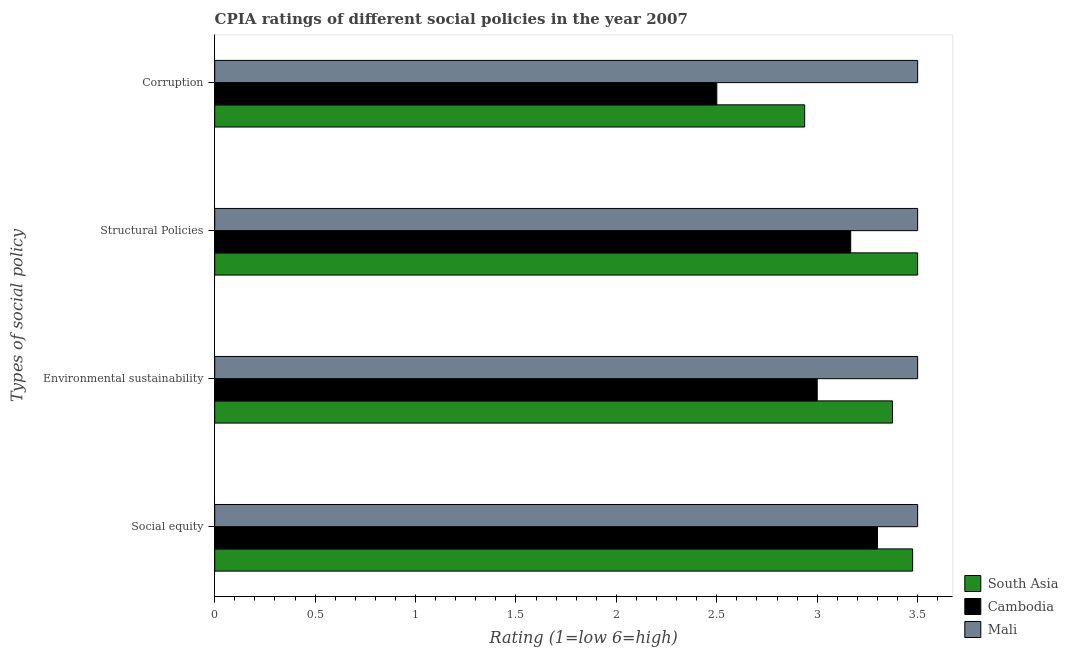How many groups of bars are there?
Provide a succinct answer. 4. Are the number of bars per tick equal to the number of legend labels?
Your response must be concise. Yes. Are the number of bars on each tick of the Y-axis equal?
Provide a succinct answer. Yes. How many bars are there on the 1st tick from the top?
Ensure brevity in your answer.  3. What is the label of the 4th group of bars from the top?
Ensure brevity in your answer.  Social equity. Across all countries, what is the maximum cpia rating of environmental sustainability?
Your response must be concise. 3.5. Across all countries, what is the minimum cpia rating of structural policies?
Ensure brevity in your answer.  3.17. In which country was the cpia rating of structural policies maximum?
Your answer should be very brief. South Asia. In which country was the cpia rating of corruption minimum?
Offer a terse response. Cambodia. What is the total cpia rating of environmental sustainability in the graph?
Offer a terse response. 9.88. What is the difference between the cpia rating of structural policies in South Asia and that in Cambodia?
Your response must be concise. 0.33. What is the difference between the cpia rating of corruption in South Asia and the cpia rating of structural policies in Cambodia?
Make the answer very short. -0.23. What is the average cpia rating of structural policies per country?
Make the answer very short. 3.39. What is the difference between the cpia rating of corruption and cpia rating of structural policies in Cambodia?
Offer a very short reply. -0.67. What is the ratio of the cpia rating of corruption in South Asia to that in Cambodia?
Give a very brief answer. 1.18. Is the difference between the cpia rating of social equity in Cambodia and Mali greater than the difference between the cpia rating of corruption in Cambodia and Mali?
Make the answer very short. Yes. What is the difference between the highest and the second highest cpia rating of corruption?
Offer a terse response. 0.56. What is the difference between the highest and the lowest cpia rating of environmental sustainability?
Your answer should be very brief. 0.5. In how many countries, is the cpia rating of corruption greater than the average cpia rating of corruption taken over all countries?
Keep it short and to the point. 1. Is the sum of the cpia rating of structural policies in Mali and Cambodia greater than the maximum cpia rating of corruption across all countries?
Ensure brevity in your answer.  Yes. Is it the case that in every country, the sum of the cpia rating of structural policies and cpia rating of corruption is greater than the sum of cpia rating of social equity and cpia rating of environmental sustainability?
Your answer should be very brief. No. What does the 3rd bar from the top in Structural Policies represents?
Give a very brief answer. South Asia. What does the 2nd bar from the bottom in Structural Policies represents?
Provide a succinct answer. Cambodia. What is the difference between two consecutive major ticks on the X-axis?
Your response must be concise. 0.5. Are the values on the major ticks of X-axis written in scientific E-notation?
Your answer should be compact. No. Does the graph contain any zero values?
Make the answer very short. No. Does the graph contain grids?
Provide a succinct answer. No. How many legend labels are there?
Keep it short and to the point. 3. How are the legend labels stacked?
Keep it short and to the point. Vertical. What is the title of the graph?
Give a very brief answer. CPIA ratings of different social policies in the year 2007. Does "High income: nonOECD" appear as one of the legend labels in the graph?
Your answer should be compact. No. What is the label or title of the Y-axis?
Your response must be concise. Types of social policy. What is the Rating (1=low 6=high) of South Asia in Social equity?
Your answer should be compact. 3.48. What is the Rating (1=low 6=high) in Mali in Social equity?
Offer a very short reply. 3.5. What is the Rating (1=low 6=high) of South Asia in Environmental sustainability?
Give a very brief answer. 3.38. What is the Rating (1=low 6=high) in Cambodia in Environmental sustainability?
Your response must be concise. 3. What is the Rating (1=low 6=high) in Mali in Environmental sustainability?
Provide a short and direct response. 3.5. What is the Rating (1=low 6=high) in South Asia in Structural Policies?
Provide a succinct answer. 3.5. What is the Rating (1=low 6=high) in Cambodia in Structural Policies?
Ensure brevity in your answer.  3.17. What is the Rating (1=low 6=high) in Mali in Structural Policies?
Keep it short and to the point. 3.5. What is the Rating (1=low 6=high) in South Asia in Corruption?
Keep it short and to the point. 2.94. Across all Types of social policy, what is the maximum Rating (1=low 6=high) in Mali?
Offer a very short reply. 3.5. Across all Types of social policy, what is the minimum Rating (1=low 6=high) in South Asia?
Keep it short and to the point. 2.94. What is the total Rating (1=low 6=high) of South Asia in the graph?
Keep it short and to the point. 13.29. What is the total Rating (1=low 6=high) of Cambodia in the graph?
Provide a short and direct response. 11.97. What is the total Rating (1=low 6=high) of Mali in the graph?
Offer a very short reply. 14. What is the difference between the Rating (1=low 6=high) in South Asia in Social equity and that in Environmental sustainability?
Your answer should be very brief. 0.1. What is the difference between the Rating (1=low 6=high) of Cambodia in Social equity and that in Environmental sustainability?
Your response must be concise. 0.3. What is the difference between the Rating (1=low 6=high) of South Asia in Social equity and that in Structural Policies?
Ensure brevity in your answer.  -0.03. What is the difference between the Rating (1=low 6=high) in Cambodia in Social equity and that in Structural Policies?
Your answer should be compact. 0.13. What is the difference between the Rating (1=low 6=high) in South Asia in Social equity and that in Corruption?
Give a very brief answer. 0.54. What is the difference between the Rating (1=low 6=high) of Mali in Social equity and that in Corruption?
Your answer should be compact. 0. What is the difference between the Rating (1=low 6=high) in South Asia in Environmental sustainability and that in Structural Policies?
Make the answer very short. -0.12. What is the difference between the Rating (1=low 6=high) of Mali in Environmental sustainability and that in Structural Policies?
Your answer should be compact. 0. What is the difference between the Rating (1=low 6=high) in South Asia in Environmental sustainability and that in Corruption?
Your response must be concise. 0.44. What is the difference between the Rating (1=low 6=high) in Cambodia in Environmental sustainability and that in Corruption?
Keep it short and to the point. 0.5. What is the difference between the Rating (1=low 6=high) in South Asia in Structural Policies and that in Corruption?
Offer a very short reply. 0.56. What is the difference between the Rating (1=low 6=high) in Mali in Structural Policies and that in Corruption?
Provide a succinct answer. 0. What is the difference between the Rating (1=low 6=high) of South Asia in Social equity and the Rating (1=low 6=high) of Cambodia in Environmental sustainability?
Your response must be concise. 0.47. What is the difference between the Rating (1=low 6=high) of South Asia in Social equity and the Rating (1=low 6=high) of Mali in Environmental sustainability?
Offer a terse response. -0.03. What is the difference between the Rating (1=low 6=high) of Cambodia in Social equity and the Rating (1=low 6=high) of Mali in Environmental sustainability?
Provide a succinct answer. -0.2. What is the difference between the Rating (1=low 6=high) in South Asia in Social equity and the Rating (1=low 6=high) in Cambodia in Structural Policies?
Your answer should be very brief. 0.31. What is the difference between the Rating (1=low 6=high) of South Asia in Social equity and the Rating (1=low 6=high) of Mali in Structural Policies?
Give a very brief answer. -0.03. What is the difference between the Rating (1=low 6=high) in South Asia in Social equity and the Rating (1=low 6=high) in Mali in Corruption?
Your answer should be compact. -0.03. What is the difference between the Rating (1=low 6=high) in Cambodia in Social equity and the Rating (1=low 6=high) in Mali in Corruption?
Your answer should be compact. -0.2. What is the difference between the Rating (1=low 6=high) of South Asia in Environmental sustainability and the Rating (1=low 6=high) of Cambodia in Structural Policies?
Your response must be concise. 0.21. What is the difference between the Rating (1=low 6=high) in South Asia in Environmental sustainability and the Rating (1=low 6=high) in Mali in Structural Policies?
Your answer should be compact. -0.12. What is the difference between the Rating (1=low 6=high) in Cambodia in Environmental sustainability and the Rating (1=low 6=high) in Mali in Structural Policies?
Give a very brief answer. -0.5. What is the difference between the Rating (1=low 6=high) in South Asia in Environmental sustainability and the Rating (1=low 6=high) in Cambodia in Corruption?
Offer a terse response. 0.88. What is the difference between the Rating (1=low 6=high) in South Asia in Environmental sustainability and the Rating (1=low 6=high) in Mali in Corruption?
Offer a terse response. -0.12. What is the difference between the Rating (1=low 6=high) of Cambodia in Environmental sustainability and the Rating (1=low 6=high) of Mali in Corruption?
Your answer should be very brief. -0.5. What is the difference between the Rating (1=low 6=high) of South Asia in Structural Policies and the Rating (1=low 6=high) of Cambodia in Corruption?
Your answer should be very brief. 1. What is the difference between the Rating (1=low 6=high) in South Asia in Structural Policies and the Rating (1=low 6=high) in Mali in Corruption?
Provide a succinct answer. 0. What is the difference between the Rating (1=low 6=high) in Cambodia in Structural Policies and the Rating (1=low 6=high) in Mali in Corruption?
Make the answer very short. -0.33. What is the average Rating (1=low 6=high) of South Asia per Types of social policy?
Your answer should be very brief. 3.32. What is the average Rating (1=low 6=high) in Cambodia per Types of social policy?
Your answer should be compact. 2.99. What is the difference between the Rating (1=low 6=high) in South Asia and Rating (1=low 6=high) in Cambodia in Social equity?
Your response must be concise. 0.17. What is the difference between the Rating (1=low 6=high) in South Asia and Rating (1=low 6=high) in Mali in Social equity?
Your answer should be very brief. -0.03. What is the difference between the Rating (1=low 6=high) of Cambodia and Rating (1=low 6=high) of Mali in Social equity?
Provide a short and direct response. -0.2. What is the difference between the Rating (1=low 6=high) of South Asia and Rating (1=low 6=high) of Mali in Environmental sustainability?
Your answer should be compact. -0.12. What is the difference between the Rating (1=low 6=high) of South Asia and Rating (1=low 6=high) of Mali in Structural Policies?
Keep it short and to the point. 0. What is the difference between the Rating (1=low 6=high) of Cambodia and Rating (1=low 6=high) of Mali in Structural Policies?
Your answer should be compact. -0.33. What is the difference between the Rating (1=low 6=high) in South Asia and Rating (1=low 6=high) in Cambodia in Corruption?
Offer a terse response. 0.44. What is the difference between the Rating (1=low 6=high) of South Asia and Rating (1=low 6=high) of Mali in Corruption?
Your answer should be compact. -0.56. What is the ratio of the Rating (1=low 6=high) in South Asia in Social equity to that in Environmental sustainability?
Give a very brief answer. 1.03. What is the ratio of the Rating (1=low 6=high) of Cambodia in Social equity to that in Environmental sustainability?
Offer a terse response. 1.1. What is the ratio of the Rating (1=low 6=high) in Mali in Social equity to that in Environmental sustainability?
Offer a very short reply. 1. What is the ratio of the Rating (1=low 6=high) in South Asia in Social equity to that in Structural Policies?
Keep it short and to the point. 0.99. What is the ratio of the Rating (1=low 6=high) in Cambodia in Social equity to that in Structural Policies?
Keep it short and to the point. 1.04. What is the ratio of the Rating (1=low 6=high) of Mali in Social equity to that in Structural Policies?
Provide a succinct answer. 1. What is the ratio of the Rating (1=low 6=high) in South Asia in Social equity to that in Corruption?
Your response must be concise. 1.18. What is the ratio of the Rating (1=low 6=high) in Cambodia in Social equity to that in Corruption?
Provide a succinct answer. 1.32. What is the ratio of the Rating (1=low 6=high) of South Asia in Environmental sustainability to that in Structural Policies?
Offer a very short reply. 0.96. What is the ratio of the Rating (1=low 6=high) of Mali in Environmental sustainability to that in Structural Policies?
Offer a very short reply. 1. What is the ratio of the Rating (1=low 6=high) in South Asia in Environmental sustainability to that in Corruption?
Provide a short and direct response. 1.15. What is the ratio of the Rating (1=low 6=high) in Cambodia in Environmental sustainability to that in Corruption?
Your answer should be very brief. 1.2. What is the ratio of the Rating (1=low 6=high) of Mali in Environmental sustainability to that in Corruption?
Make the answer very short. 1. What is the ratio of the Rating (1=low 6=high) in South Asia in Structural Policies to that in Corruption?
Your answer should be compact. 1.19. What is the ratio of the Rating (1=low 6=high) of Cambodia in Structural Policies to that in Corruption?
Provide a short and direct response. 1.27. What is the ratio of the Rating (1=low 6=high) of Mali in Structural Policies to that in Corruption?
Keep it short and to the point. 1. What is the difference between the highest and the second highest Rating (1=low 6=high) of South Asia?
Your response must be concise. 0.03. What is the difference between the highest and the second highest Rating (1=low 6=high) of Cambodia?
Offer a terse response. 0.13. What is the difference between the highest and the second highest Rating (1=low 6=high) in Mali?
Provide a short and direct response. 0. What is the difference between the highest and the lowest Rating (1=low 6=high) in South Asia?
Your answer should be very brief. 0.56. What is the difference between the highest and the lowest Rating (1=low 6=high) in Mali?
Ensure brevity in your answer.  0. 